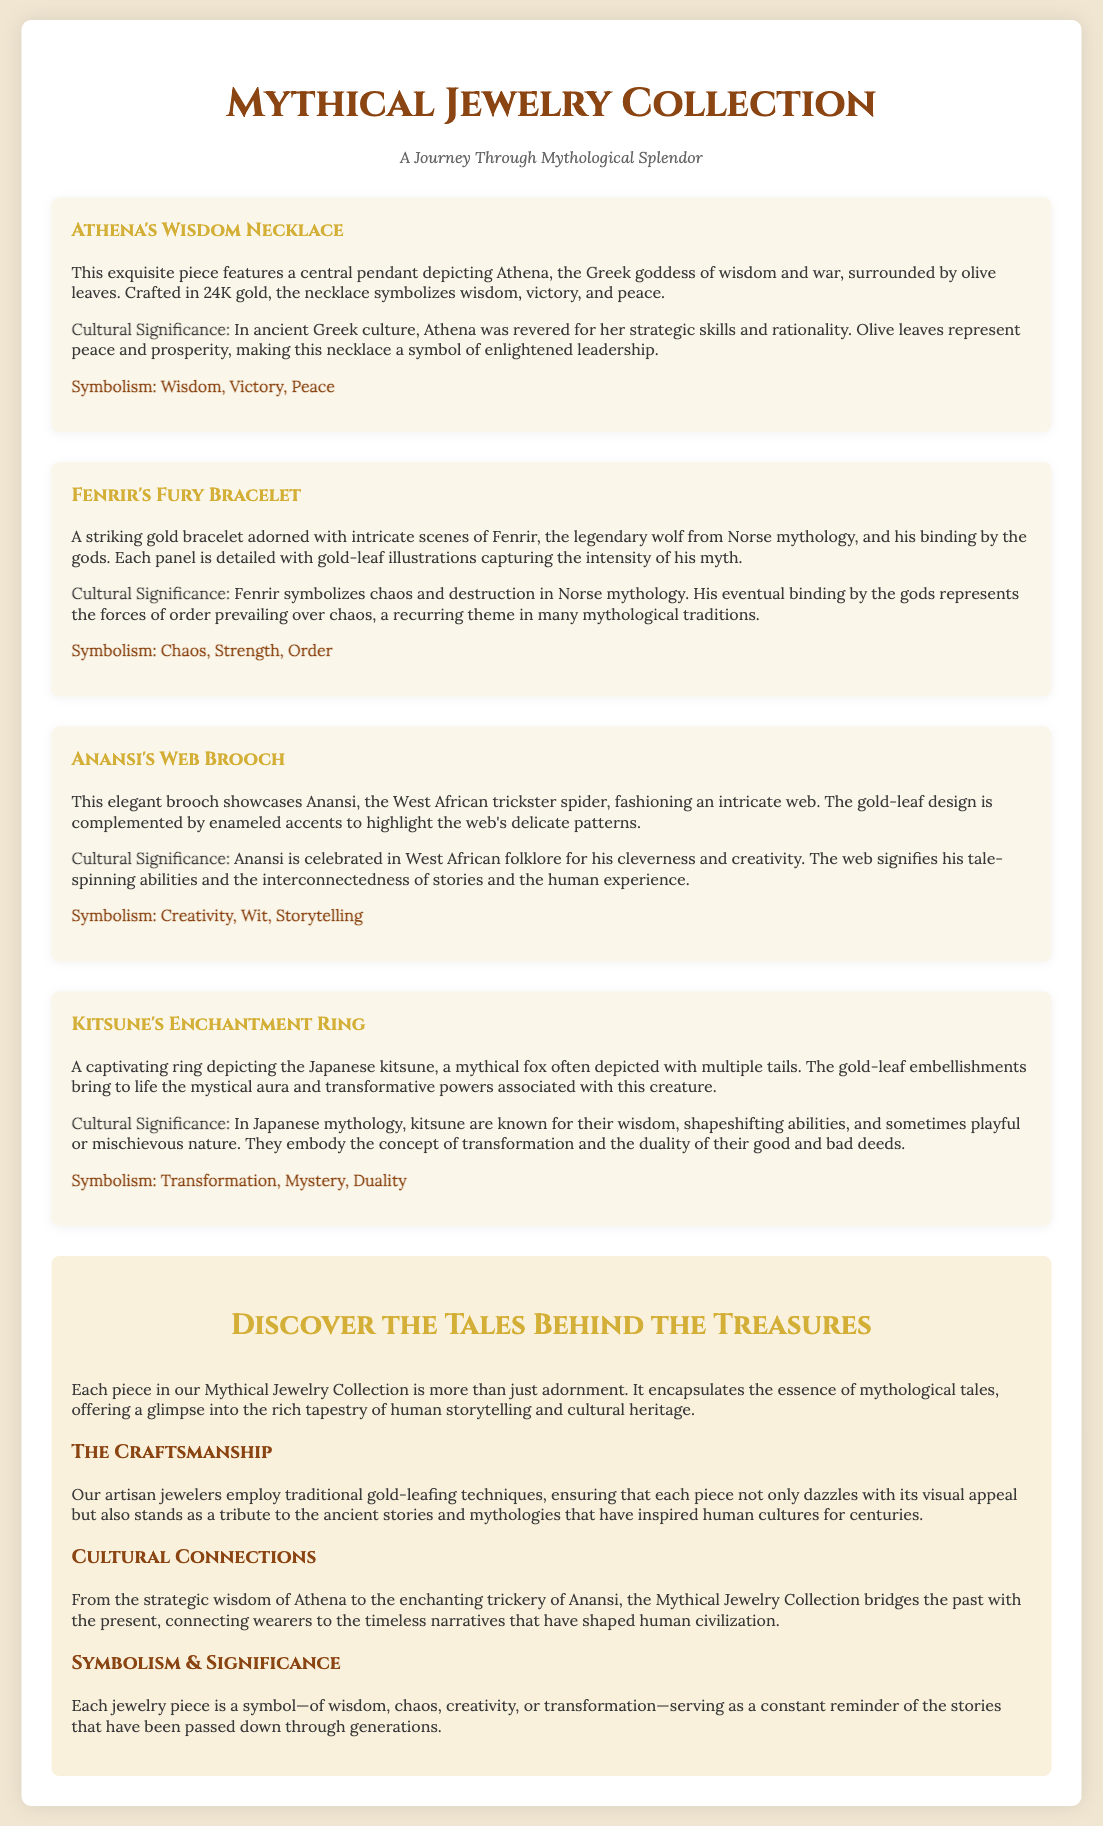What is the title of the collection? The title of the collection is prominently displayed as the main heading of the document.
Answer: Mythical Jewelry Collection What does the Athena's Wisdom Necklace symbolize? The symbolism is listed under each item and reflects its cultural significance.
Answer: Wisdom, Victory, Peace Which mythical creature is featured in the Kitsune's Enchantment Ring? The specific creature represented in the ring is mentioned in the description of the item.
Answer: Kitsune How many sections are included in the leaflet? The leaflet has distinct sections that are explicitly labeled as subsections within it.
Answer: Three What type of gold is used in the Athena's Wisdom Necklace? The document specifies the type of gold used in crafting the necklace.
Answer: 24K gold What theme does Fenrir's Fury Bracelet represent? The document outlines the themes associated with each jewelry piece.
Answer: Chaos, Strength, Order Who is Anansi in mythology? The document describes Anansi's role and cultural context in West African folklore.
Answer: Trickster spider What is the craftsmanship technique mentioned for the jewelry pieces? The document details the artisan attribute related to the making of the jewelry.
Answer: Gold-leafing techniques 